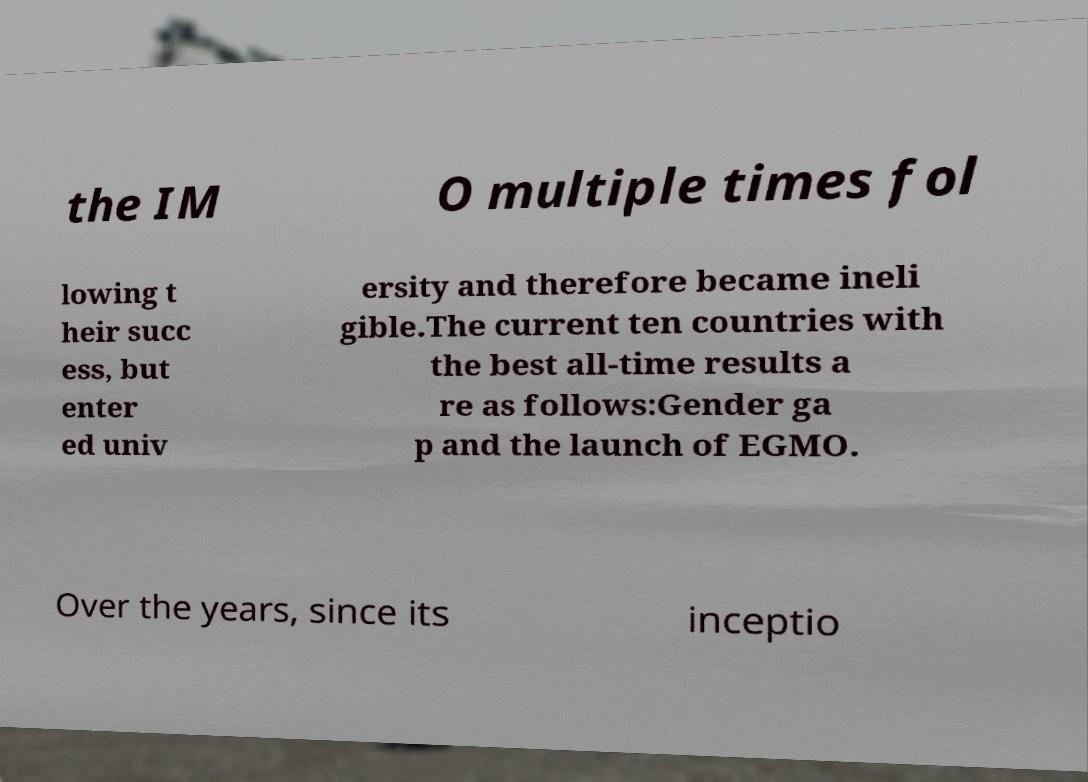Can you accurately transcribe the text from the provided image for me? the IM O multiple times fol lowing t heir succ ess, but enter ed univ ersity and therefore became ineli gible.The current ten countries with the best all-time results a re as follows:Gender ga p and the launch of EGMO. Over the years, since its inceptio 